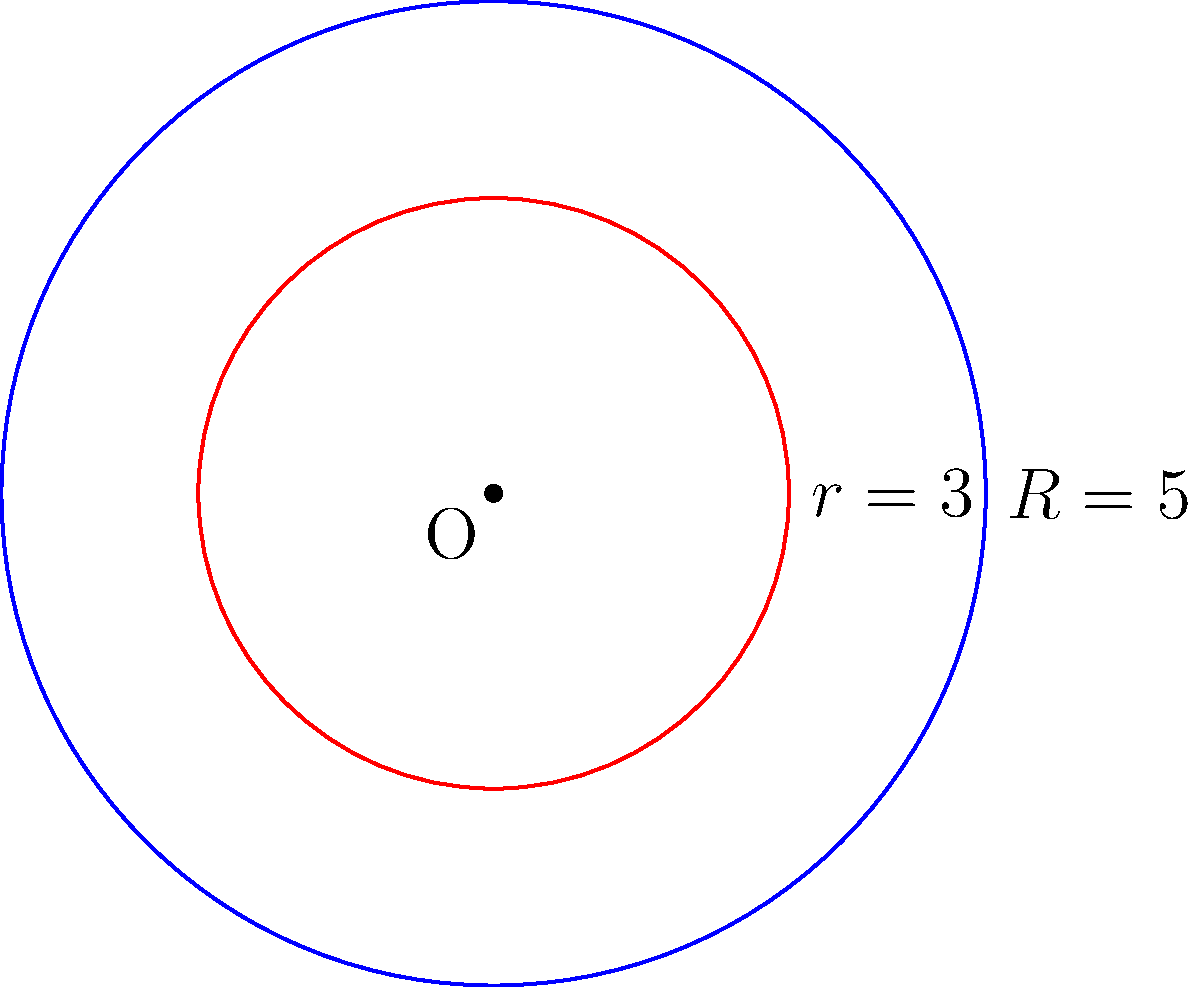As a parent who has witnessed your child's resilience in overcoming meningitis, you understand the importance of precise measurements. In a similar vein, consider two concentric circles with radii $R = 5$ cm and $r = 3$ cm. Calculate the area of the region between these two circles, representing the space where hope and recovery flourish. Let's approach this step-by-step:

1) The area between two concentric circles is the difference between the areas of the larger and smaller circles.

2) Area of a circle is given by the formula $A = \pi r^2$, where $r$ is the radius.

3) For the larger circle:
   $A_1 = \pi R^2 = \pi (5 \text{ cm})^2 = 25\pi \text{ cm}^2$

4) For the smaller circle:
   $A_2 = \pi r^2 = \pi (3 \text{ cm})^2 = 9\pi \text{ cm}^2$

5) The area between the circles is:
   $A = A_1 - A_2 = 25\pi \text{ cm}^2 - 9\pi \text{ cm}^2 = 16\pi \text{ cm}^2$

This area represents the space between challenges and triumphs, much like the journey through meningitis recovery.
Answer: $16\pi \text{ cm}^2$ 